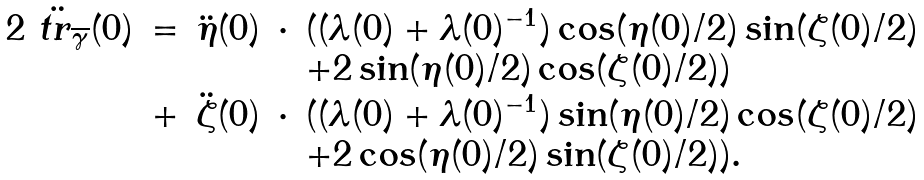Convert formula to latex. <formula><loc_0><loc_0><loc_500><loc_500>\begin{array} { l l l l l } 2 \ddot { \ t r _ { \overline { \gamma } } } ( 0 ) & = & \ddot { \eta } ( 0 ) & \cdot & ( ( \lambda ( 0 ) + \lambda ( 0 ) ^ { - 1 } ) \cos ( \eta ( 0 ) / 2 ) \sin ( \zeta ( 0 ) / 2 ) \\ & & & & + 2 \sin ( \eta ( 0 ) / 2 ) \cos ( \zeta ( 0 ) / 2 ) ) \\ & + & \ddot { \zeta } ( 0 ) & \cdot & ( ( \lambda ( 0 ) + \lambda ( 0 ) ^ { - 1 } ) \sin ( \eta ( 0 ) / 2 ) \cos ( \zeta ( 0 ) / 2 ) \\ & & & & + 2 \cos ( \eta ( 0 ) / 2 ) \sin ( \zeta ( 0 ) / 2 ) ) . \end{array}</formula> 